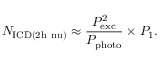Convert formula to latex. <formula><loc_0><loc_0><loc_500><loc_500>N _ { I C D ( 2 h \ n u ) } \approx \frac { P _ { e x c } ^ { 2 } } { P _ { p h o t o } } \times P _ { 1 } .</formula> 